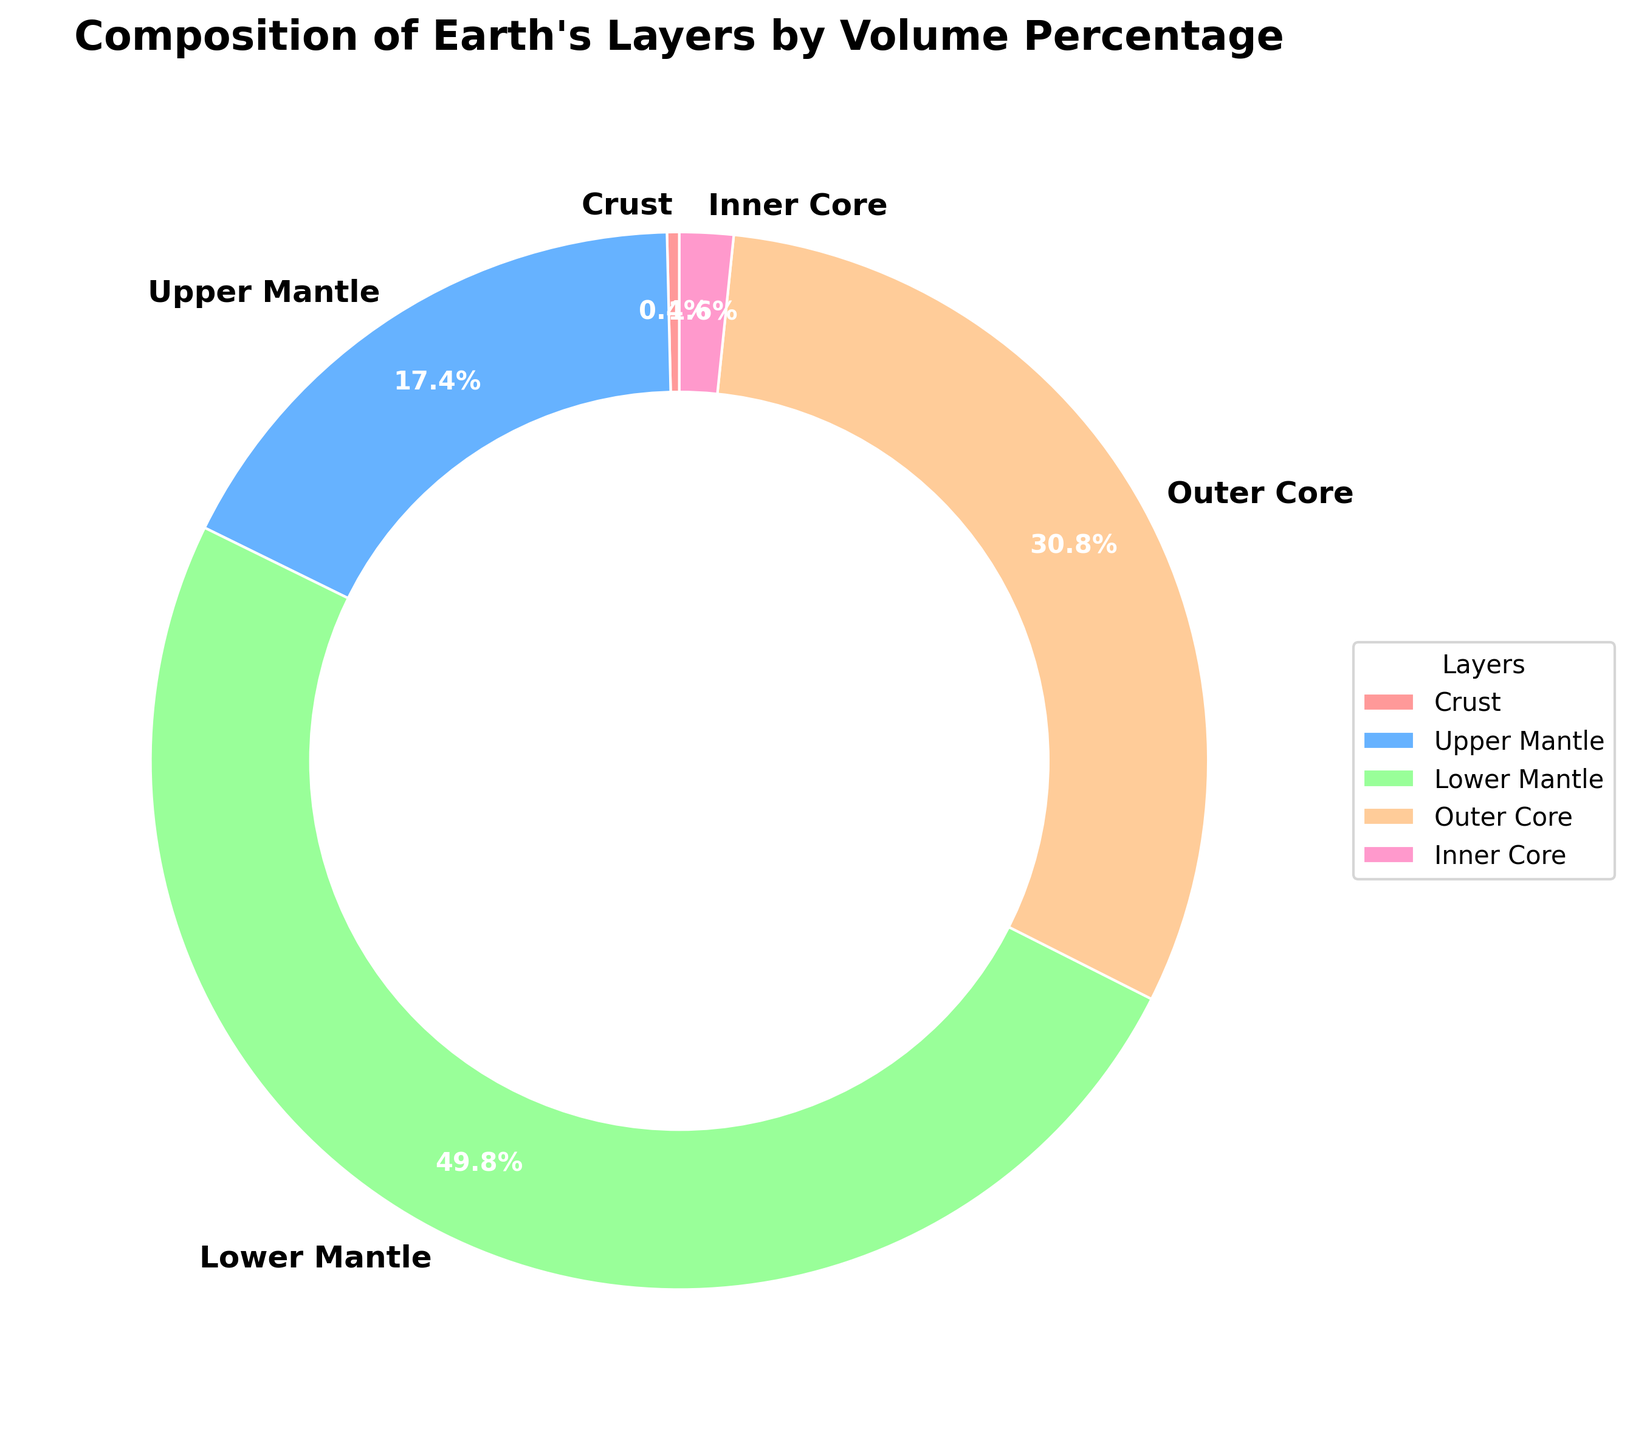Which layer has the largest volume percentage? By visually inspecting the pie chart, you can see that the Lower Mantle section has the largest size relative to the other sections.
Answer: Lower Mantle What is the total volume percentage of the crust and the inner core? Sum the volume percentages for the Crust (0.374%) and the Inner Core (1.642%): 0.374 + 1.642 = 2.016%
Answer: 2.016% Which layer has a volume percentage closest to 50%? By visually inspecting the values in the labels, you'll notice that the Lower Mantle has a volume percentage of 49.828%, which is closest to 50%.
Answer: Lower Mantle Compare the volume percentage of the Outer Core to the Upper Mantle. Which one is larger? By comparing the values, the Outer Core has a volume percentage of 30.795%, while the Upper Mantle has 17.361%. Therefore, the Outer Core is larger.
Answer: Outer Core What is the combined volume percentage of the Mantle (both Upper and Lower)? Sum the volume percentages for the Upper Mantle (17.361%) and Lower Mantle (49.828%): 17.361 + 49.828 = 67.189%
Answer: 67.189% Which layer is represented by the red color in the pie chart? By visually identifying the color coding in the pie chart, the Crust layer is represented by the red section.
Answer: Crust How much larger is the volume percentage of the Lower Mantle compared to the Inner Core? Subtract the Inner Core percentage (1.642%) from the Lower Mantle percentage (49.828%): 49.828 - 1.642 = 48.186%
Answer: 48.186% Is the total volume percentage of the Mantle greater than 60%? Sum the volume percentages of the Upper Mantle (17.361%) and Lower Mantle (49.828%): 17.361 + 49.828 = 67.189%, which is greater than 60%.
Answer: Yes Which layer constitutes less than 1% of the Earth's volume? By examining the values, the Crust has a percentage of 0.374%, which is less than 1%.
Answer: Crust 